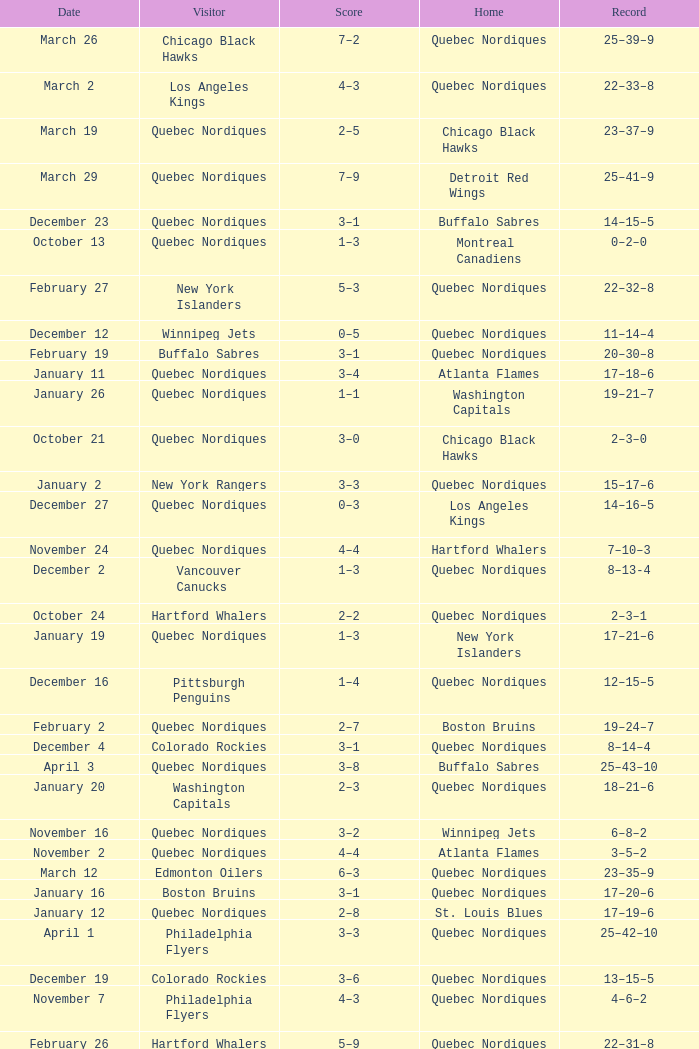Which Record has a Home of edmonton oilers, and a Score of 3–6? 1–3–0. 